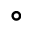Convert formula to latex. <formula><loc_0><loc_0><loc_500><loc_500>^ { \circ }</formula> 